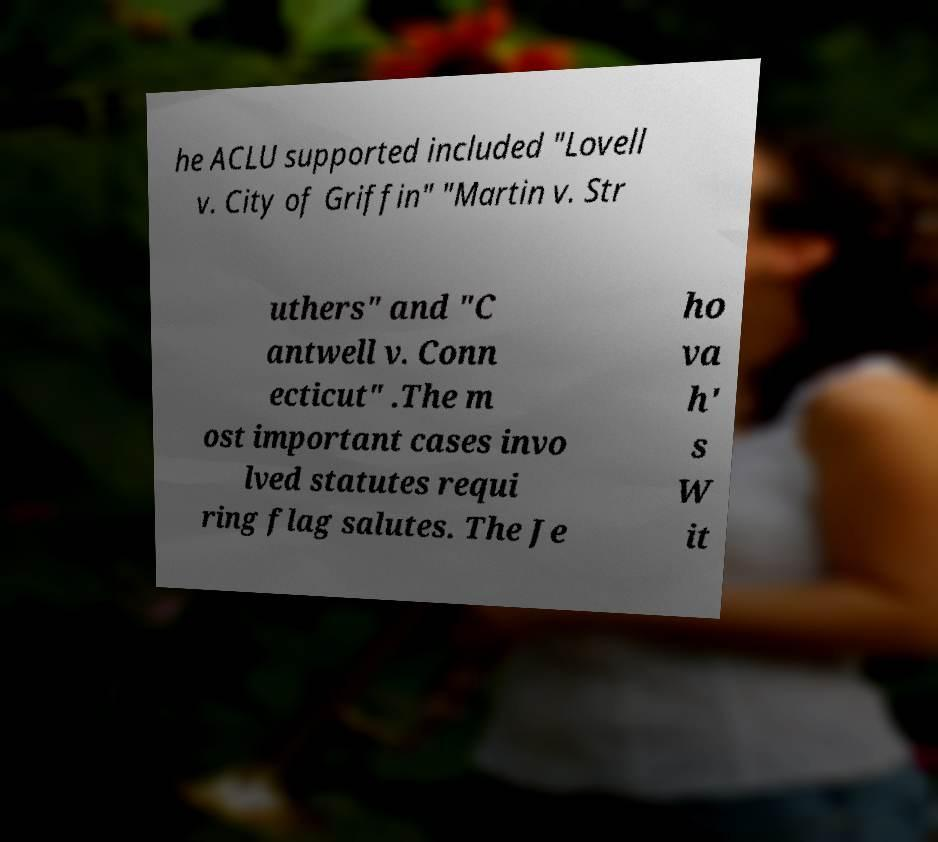Could you extract and type out the text from this image? he ACLU supported included "Lovell v. City of Griffin" "Martin v. Str uthers" and "C antwell v. Conn ecticut" .The m ost important cases invo lved statutes requi ring flag salutes. The Je ho va h' s W it 